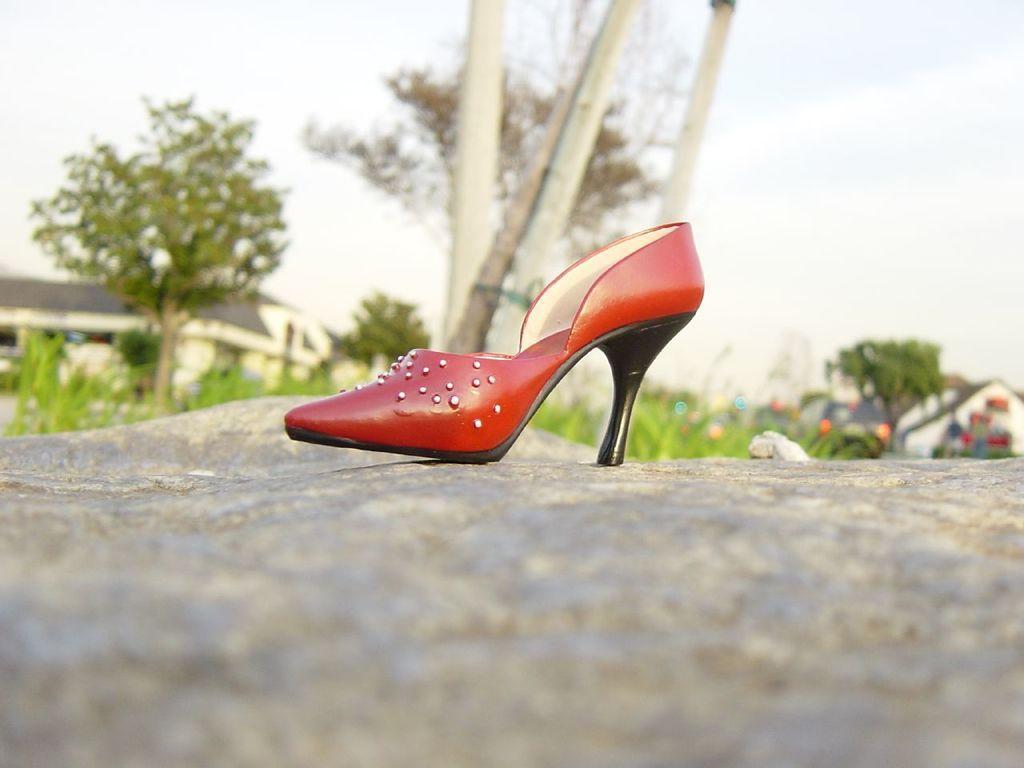Describe this image in one or two sentences. In this picture we can see footwear on a rock surface. In the background we can see grass, trees, houses, and sky. 